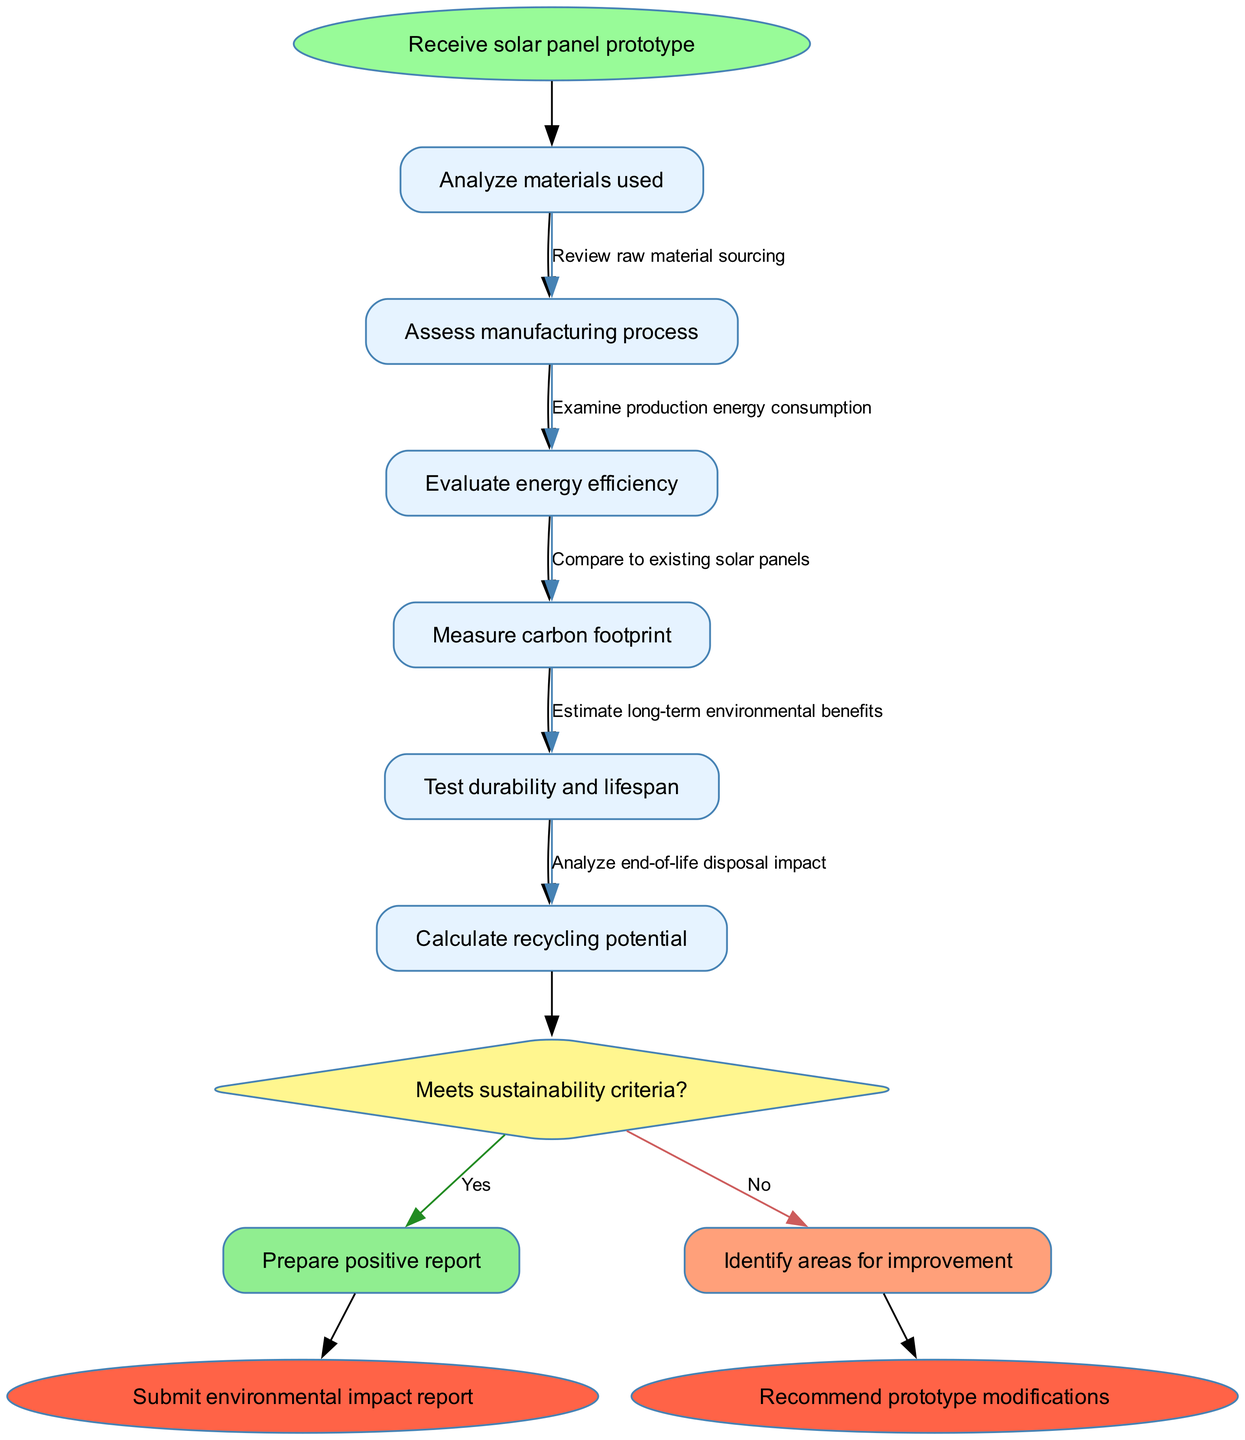What is the starting node in the diagram? The starting node is defined in the data provided as "Receive solar panel prototype." It is the first activity that represents the initiation of the environmental impact assessment process.
Answer: Receive solar panel prototype How many activities are there in the diagram? The diagram lists six activities as per the data section, specifying each task that needs to be completed during the assessment.
Answer: 6 What question is posed at the decision node? The decision node contains the question "Meets sustainability criteria?" This question evaluates whether the prototype is suitable for sustainability standards.
Answer: Meets sustainability criteria? What happens if the answer to the decision is "No"? If the answer is "No," the process branches to the node labeled "Identify areas for improvement," indicating that further assessment is required to enhance the prototype's sustainability.
Answer: Identify areas for improvement What is the last action before reaching the decision node? The last action leading to the decision node is "Test durability and lifespan," which occurs right before evaluating if the sustainability criteria are met.
Answer: Test durability and lifespan What color represents the end nodes in the diagram? The end nodes are represented with a fill color of "#FF6347," which corresponds to a reddish shade in the diagram, indicating a conclusion to the assessment process.
Answer: #FF6347 How do you move from the "Prepare positive report" to the end nodes? After preparing a positive report, you directly edge to the end node "Submit environmental impact report." This indicates the completion of the positive assessment cycle.
Answer: Submit environmental impact report What is the connection between the "Analyze materials used" and "Assess manufacturing process"? The connection indicates that "Assess manufacturing process" follows directly after "Analyze materials used," suggesting a sequential assessment where the outcome of one informs the next step.
Answer: Examine production energy consumption What is the purpose of the "Calculate recycling potential" activity? The purpose is to assess how well the solar panel prototype can be recycled after its lifespan, providing insights into its sustainability and environmental impact.
Answer: Assess recycling potential 